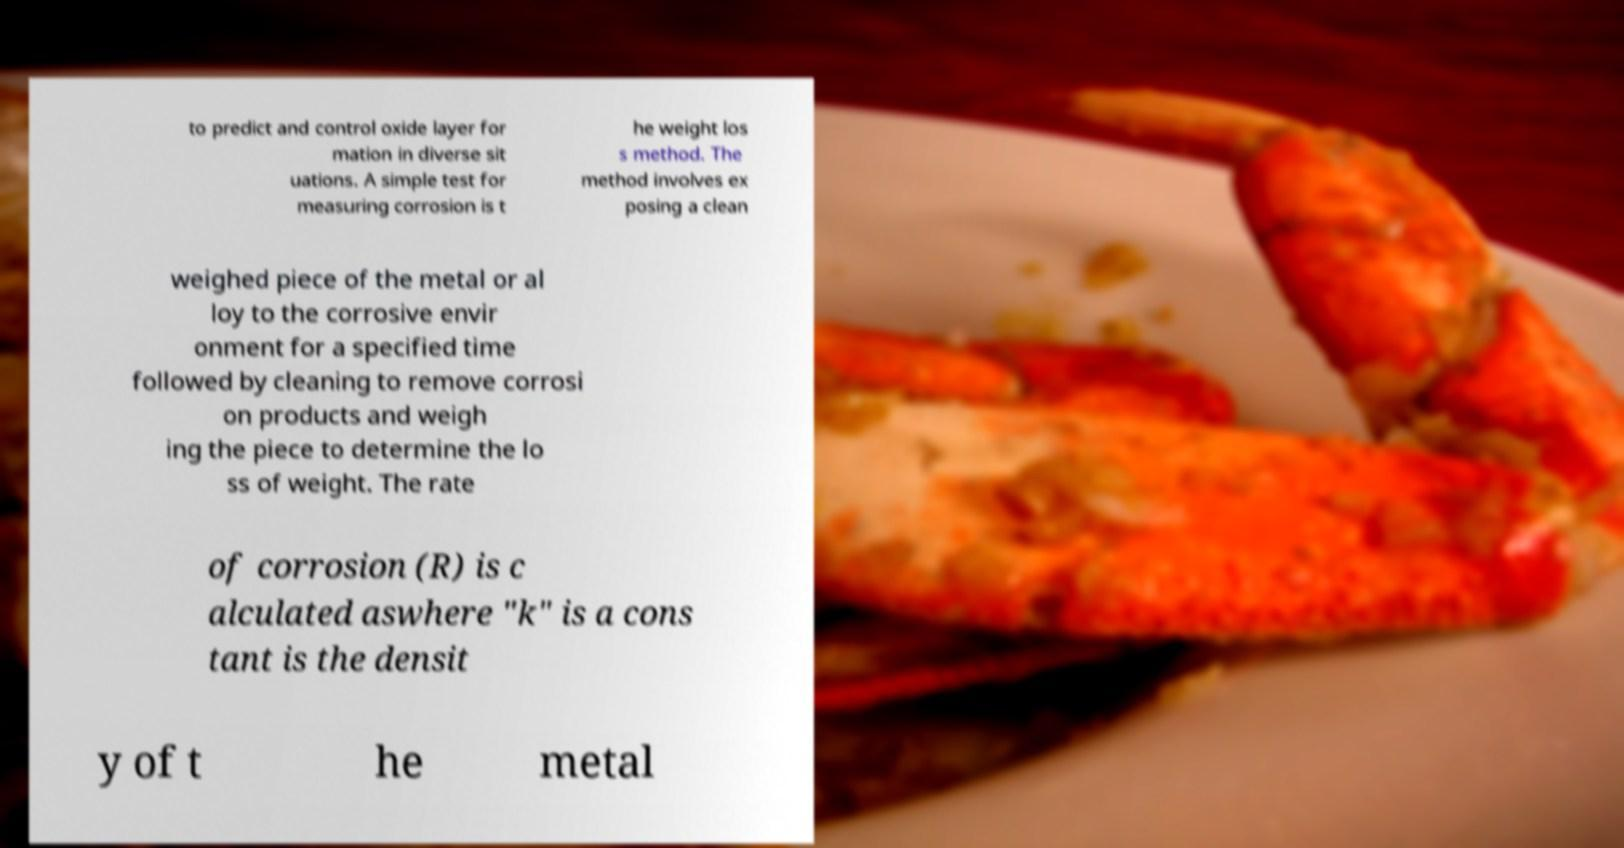Can you read and provide the text displayed in the image?This photo seems to have some interesting text. Can you extract and type it out for me? to predict and control oxide layer for mation in diverse sit uations. A simple test for measuring corrosion is t he weight los s method. The method involves ex posing a clean weighed piece of the metal or al loy to the corrosive envir onment for a specified time followed by cleaning to remove corrosi on products and weigh ing the piece to determine the lo ss of weight. The rate of corrosion (R) is c alculated aswhere "k" is a cons tant is the densit y of t he metal 